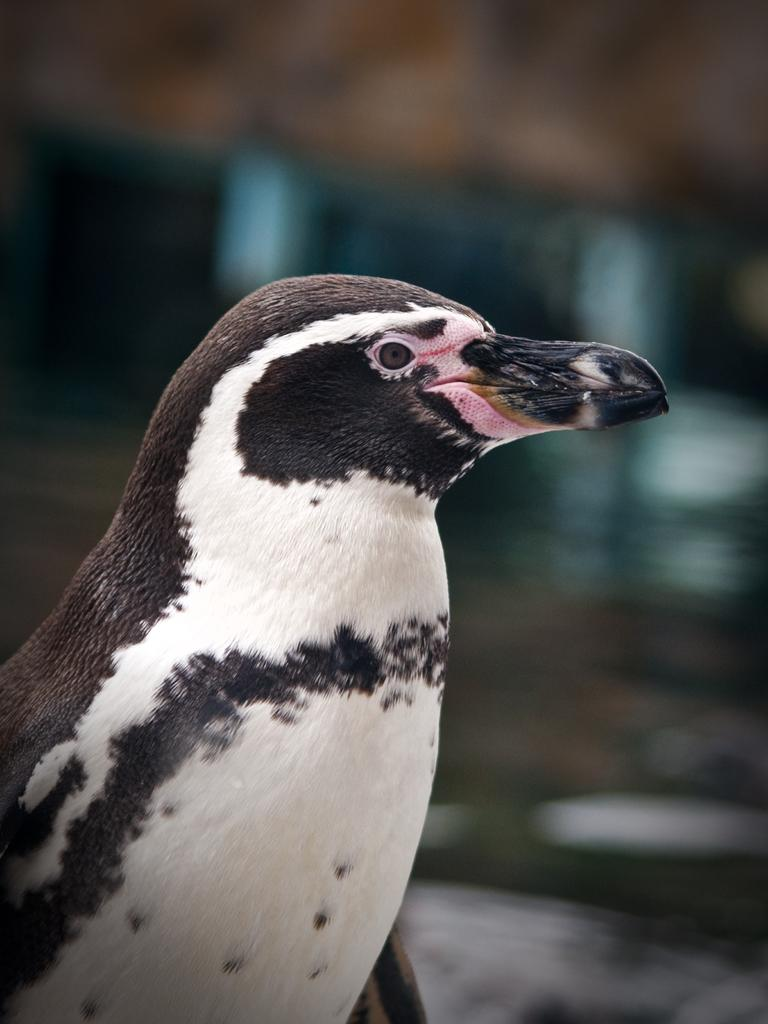What type of animal can be seen in the image? There is a bird in the image. Can you describe the background of the image? The background of the image is blurred. What size of fireman is visible in the image? There is no fireman present in the image, so it is not possible to determine the size of a fireman. 